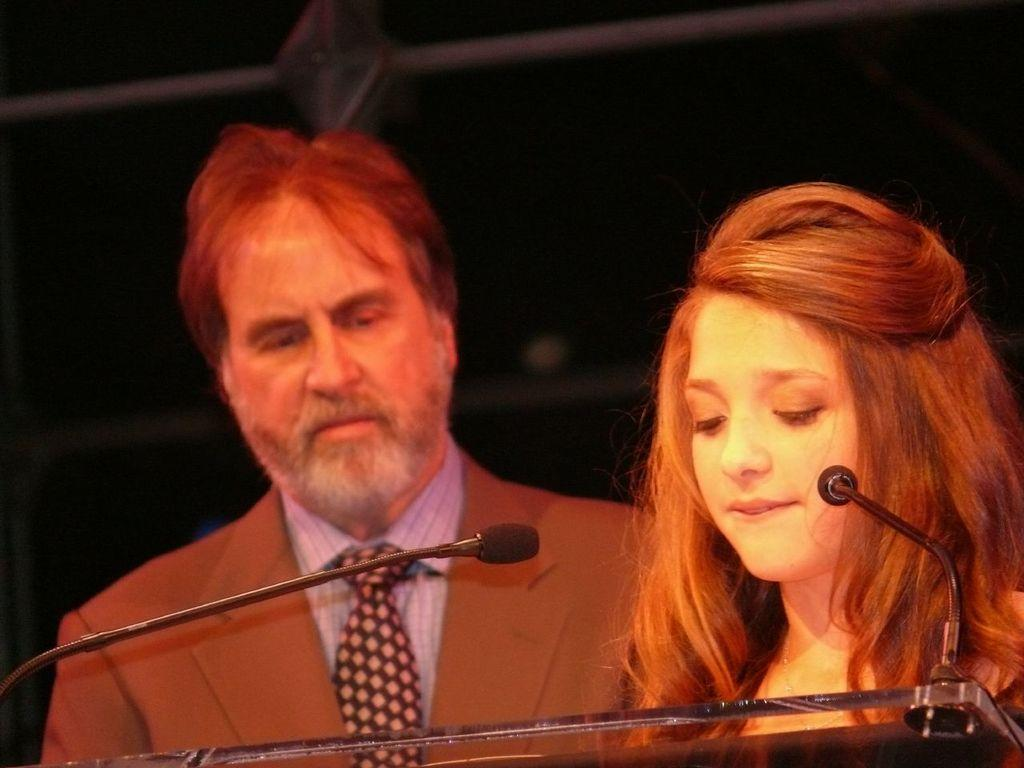How many people are present in the image? There are two persons standing at a desk in the image. What can be seen in the background of the image? There is a wall visible in the background. What type of wealth is displayed on the desk in the image? There is no indication of wealth displayed on the desk in the image. How does the wall stop the view of the other side in the image? The wall does not stop the view of the other side in the image; it is visible in the background, allowing a view of the area beyond it. 